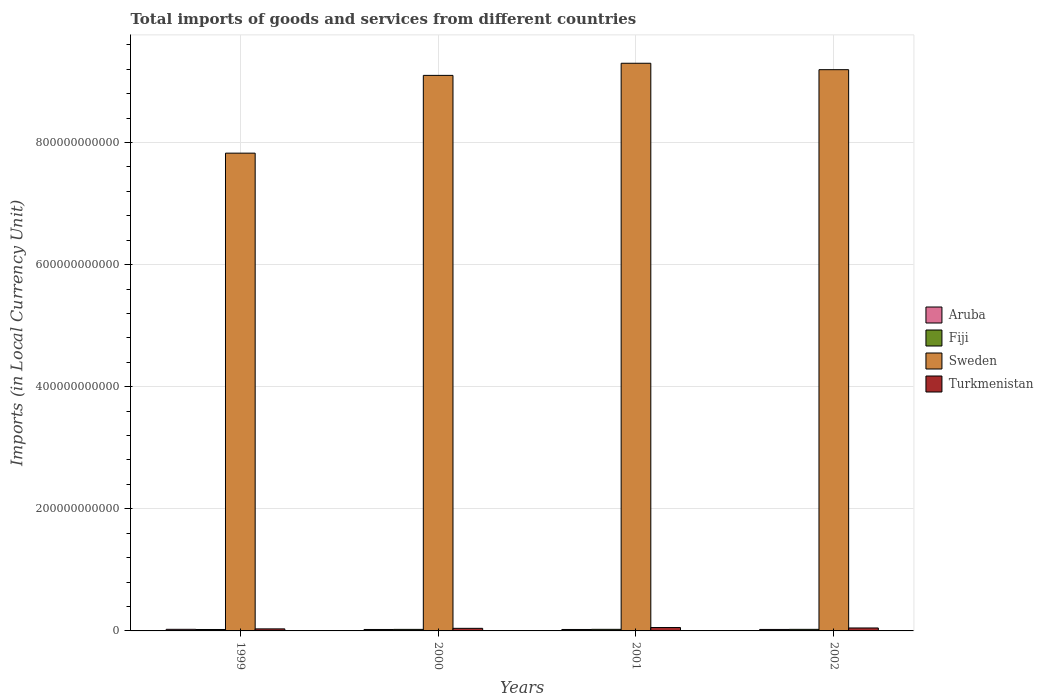How many groups of bars are there?
Your answer should be very brief. 4. Are the number of bars on each tick of the X-axis equal?
Offer a terse response. Yes. How many bars are there on the 3rd tick from the left?
Make the answer very short. 4. How many bars are there on the 4th tick from the right?
Provide a short and direct response. 4. What is the Amount of goods and services imports in Fiji in 1999?
Offer a terse response. 2.35e+09. Across all years, what is the maximum Amount of goods and services imports in Sweden?
Ensure brevity in your answer.  9.30e+11. Across all years, what is the minimum Amount of goods and services imports in Aruba?
Keep it short and to the point. 2.36e+09. In which year was the Amount of goods and services imports in Fiji maximum?
Provide a succinct answer. 2001. What is the total Amount of goods and services imports in Turkmenistan in the graph?
Your answer should be compact. 1.80e+1. What is the difference between the Amount of goods and services imports in Turkmenistan in 2001 and that in 2002?
Offer a very short reply. 7.11e+08. What is the difference between the Amount of goods and services imports in Fiji in 2000 and the Amount of goods and services imports in Turkmenistan in 2002?
Provide a short and direct response. -2.31e+09. What is the average Amount of goods and services imports in Turkmenistan per year?
Keep it short and to the point. 4.49e+09. In the year 2001, what is the difference between the Amount of goods and services imports in Sweden and Amount of goods and services imports in Aruba?
Your answer should be very brief. 9.27e+11. What is the ratio of the Amount of goods and services imports in Turkmenistan in 2000 to that in 2002?
Give a very brief answer. 0.87. Is the difference between the Amount of goods and services imports in Sweden in 2000 and 2001 greater than the difference between the Amount of goods and services imports in Aruba in 2000 and 2001?
Ensure brevity in your answer.  No. What is the difference between the highest and the second highest Amount of goods and services imports in Turkmenistan?
Provide a succinct answer. 7.11e+08. What is the difference between the highest and the lowest Amount of goods and services imports in Sweden?
Make the answer very short. 1.47e+11. In how many years, is the Amount of goods and services imports in Fiji greater than the average Amount of goods and services imports in Fiji taken over all years?
Your answer should be very brief. 3. Is the sum of the Amount of goods and services imports in Turkmenistan in 1999 and 2001 greater than the maximum Amount of goods and services imports in Fiji across all years?
Offer a very short reply. Yes. Is it the case that in every year, the sum of the Amount of goods and services imports in Turkmenistan and Amount of goods and services imports in Aruba is greater than the sum of Amount of goods and services imports in Fiji and Amount of goods and services imports in Sweden?
Give a very brief answer. Yes. What does the 2nd bar from the left in 1999 represents?
Your answer should be very brief. Fiji. What does the 4th bar from the right in 1999 represents?
Provide a short and direct response. Aruba. How many years are there in the graph?
Provide a succinct answer. 4. What is the difference between two consecutive major ticks on the Y-axis?
Ensure brevity in your answer.  2.00e+11. Are the values on the major ticks of Y-axis written in scientific E-notation?
Your answer should be compact. No. Does the graph contain any zero values?
Offer a very short reply. No. Does the graph contain grids?
Offer a terse response. Yes. Where does the legend appear in the graph?
Make the answer very short. Center right. What is the title of the graph?
Your response must be concise. Total imports of goods and services from different countries. Does "Italy" appear as one of the legend labels in the graph?
Your answer should be very brief. No. What is the label or title of the X-axis?
Make the answer very short. Years. What is the label or title of the Y-axis?
Give a very brief answer. Imports (in Local Currency Unit). What is the Imports (in Local Currency Unit) of Aruba in 1999?
Make the answer very short. 2.61e+09. What is the Imports (in Local Currency Unit) of Fiji in 1999?
Keep it short and to the point. 2.35e+09. What is the Imports (in Local Currency Unit) of Sweden in 1999?
Keep it short and to the point. 7.83e+11. What is the Imports (in Local Currency Unit) in Turkmenistan in 1999?
Ensure brevity in your answer.  3.35e+09. What is the Imports (in Local Currency Unit) in Aruba in 2000?
Provide a succinct answer. 2.37e+09. What is the Imports (in Local Currency Unit) of Fiji in 2000?
Provide a short and direct response. 2.52e+09. What is the Imports (in Local Currency Unit) of Sweden in 2000?
Make the answer very short. 9.10e+11. What is the Imports (in Local Currency Unit) of Turkmenistan in 2000?
Give a very brief answer. 4.23e+09. What is the Imports (in Local Currency Unit) in Aruba in 2001?
Keep it short and to the point. 2.36e+09. What is the Imports (in Local Currency Unit) of Fiji in 2001?
Keep it short and to the point. 2.60e+09. What is the Imports (in Local Currency Unit) of Sweden in 2001?
Give a very brief answer. 9.30e+11. What is the Imports (in Local Currency Unit) in Turkmenistan in 2001?
Your response must be concise. 5.54e+09. What is the Imports (in Local Currency Unit) in Aruba in 2002?
Offer a terse response. 2.41e+09. What is the Imports (in Local Currency Unit) in Fiji in 2002?
Give a very brief answer. 2.58e+09. What is the Imports (in Local Currency Unit) in Sweden in 2002?
Provide a short and direct response. 9.19e+11. What is the Imports (in Local Currency Unit) in Turkmenistan in 2002?
Provide a succinct answer. 4.83e+09. Across all years, what is the maximum Imports (in Local Currency Unit) in Aruba?
Offer a very short reply. 2.61e+09. Across all years, what is the maximum Imports (in Local Currency Unit) in Fiji?
Make the answer very short. 2.60e+09. Across all years, what is the maximum Imports (in Local Currency Unit) of Sweden?
Your answer should be compact. 9.30e+11. Across all years, what is the maximum Imports (in Local Currency Unit) of Turkmenistan?
Your response must be concise. 5.54e+09. Across all years, what is the minimum Imports (in Local Currency Unit) in Aruba?
Your answer should be compact. 2.36e+09. Across all years, what is the minimum Imports (in Local Currency Unit) in Fiji?
Your answer should be compact. 2.35e+09. Across all years, what is the minimum Imports (in Local Currency Unit) in Sweden?
Offer a very short reply. 7.83e+11. Across all years, what is the minimum Imports (in Local Currency Unit) in Turkmenistan?
Give a very brief answer. 3.35e+09. What is the total Imports (in Local Currency Unit) of Aruba in the graph?
Offer a very short reply. 9.75e+09. What is the total Imports (in Local Currency Unit) of Fiji in the graph?
Your response must be concise. 1.00e+1. What is the total Imports (in Local Currency Unit) in Sweden in the graph?
Make the answer very short. 3.54e+12. What is the total Imports (in Local Currency Unit) in Turkmenistan in the graph?
Give a very brief answer. 1.80e+1. What is the difference between the Imports (in Local Currency Unit) of Aruba in 1999 and that in 2000?
Offer a terse response. 2.40e+08. What is the difference between the Imports (in Local Currency Unit) in Fiji in 1999 and that in 2000?
Keep it short and to the point. -1.69e+08. What is the difference between the Imports (in Local Currency Unit) of Sweden in 1999 and that in 2000?
Your answer should be compact. -1.27e+11. What is the difference between the Imports (in Local Currency Unit) in Turkmenistan in 1999 and that in 2000?
Provide a succinct answer. -8.78e+08. What is the difference between the Imports (in Local Currency Unit) in Aruba in 1999 and that in 2001?
Keep it short and to the point. 2.54e+08. What is the difference between the Imports (in Local Currency Unit) of Fiji in 1999 and that in 2001?
Keep it short and to the point. -2.48e+08. What is the difference between the Imports (in Local Currency Unit) in Sweden in 1999 and that in 2001?
Offer a terse response. -1.47e+11. What is the difference between the Imports (in Local Currency Unit) in Turkmenistan in 1999 and that in 2001?
Make the answer very short. -2.19e+09. What is the difference between the Imports (in Local Currency Unit) of Aruba in 1999 and that in 2002?
Keep it short and to the point. 1.99e+08. What is the difference between the Imports (in Local Currency Unit) of Fiji in 1999 and that in 2002?
Your answer should be very brief. -2.26e+08. What is the difference between the Imports (in Local Currency Unit) of Sweden in 1999 and that in 2002?
Ensure brevity in your answer.  -1.37e+11. What is the difference between the Imports (in Local Currency Unit) of Turkmenistan in 1999 and that in 2002?
Your answer should be very brief. -1.48e+09. What is the difference between the Imports (in Local Currency Unit) in Aruba in 2000 and that in 2001?
Offer a very short reply. 1.48e+07. What is the difference between the Imports (in Local Currency Unit) in Fiji in 2000 and that in 2001?
Provide a succinct answer. -7.86e+07. What is the difference between the Imports (in Local Currency Unit) of Sweden in 2000 and that in 2001?
Offer a terse response. -1.99e+1. What is the difference between the Imports (in Local Currency Unit) of Turkmenistan in 2000 and that in 2001?
Give a very brief answer. -1.32e+09. What is the difference between the Imports (in Local Currency Unit) of Aruba in 2000 and that in 2002?
Provide a short and direct response. -4.09e+07. What is the difference between the Imports (in Local Currency Unit) of Fiji in 2000 and that in 2002?
Give a very brief answer. -5.72e+07. What is the difference between the Imports (in Local Currency Unit) in Sweden in 2000 and that in 2002?
Provide a short and direct response. -9.34e+09. What is the difference between the Imports (in Local Currency Unit) of Turkmenistan in 2000 and that in 2002?
Provide a succinct answer. -6.05e+08. What is the difference between the Imports (in Local Currency Unit) in Aruba in 2001 and that in 2002?
Your answer should be compact. -5.57e+07. What is the difference between the Imports (in Local Currency Unit) in Fiji in 2001 and that in 2002?
Your answer should be compact. 2.14e+07. What is the difference between the Imports (in Local Currency Unit) of Sweden in 2001 and that in 2002?
Offer a very short reply. 1.05e+1. What is the difference between the Imports (in Local Currency Unit) of Turkmenistan in 2001 and that in 2002?
Keep it short and to the point. 7.11e+08. What is the difference between the Imports (in Local Currency Unit) in Aruba in 1999 and the Imports (in Local Currency Unit) in Fiji in 2000?
Make the answer very short. 9.14e+07. What is the difference between the Imports (in Local Currency Unit) of Aruba in 1999 and the Imports (in Local Currency Unit) of Sweden in 2000?
Your answer should be very brief. -9.07e+11. What is the difference between the Imports (in Local Currency Unit) in Aruba in 1999 and the Imports (in Local Currency Unit) in Turkmenistan in 2000?
Offer a terse response. -1.62e+09. What is the difference between the Imports (in Local Currency Unit) of Fiji in 1999 and the Imports (in Local Currency Unit) of Sweden in 2000?
Your answer should be very brief. -9.08e+11. What is the difference between the Imports (in Local Currency Unit) in Fiji in 1999 and the Imports (in Local Currency Unit) in Turkmenistan in 2000?
Your answer should be very brief. -1.88e+09. What is the difference between the Imports (in Local Currency Unit) of Sweden in 1999 and the Imports (in Local Currency Unit) of Turkmenistan in 2000?
Offer a very short reply. 7.78e+11. What is the difference between the Imports (in Local Currency Unit) in Aruba in 1999 and the Imports (in Local Currency Unit) in Fiji in 2001?
Your answer should be compact. 1.28e+07. What is the difference between the Imports (in Local Currency Unit) of Aruba in 1999 and the Imports (in Local Currency Unit) of Sweden in 2001?
Provide a short and direct response. -9.27e+11. What is the difference between the Imports (in Local Currency Unit) in Aruba in 1999 and the Imports (in Local Currency Unit) in Turkmenistan in 2001?
Provide a succinct answer. -2.93e+09. What is the difference between the Imports (in Local Currency Unit) of Fiji in 1999 and the Imports (in Local Currency Unit) of Sweden in 2001?
Ensure brevity in your answer.  -9.28e+11. What is the difference between the Imports (in Local Currency Unit) of Fiji in 1999 and the Imports (in Local Currency Unit) of Turkmenistan in 2001?
Your answer should be very brief. -3.19e+09. What is the difference between the Imports (in Local Currency Unit) of Sweden in 1999 and the Imports (in Local Currency Unit) of Turkmenistan in 2001?
Make the answer very short. 7.77e+11. What is the difference between the Imports (in Local Currency Unit) of Aruba in 1999 and the Imports (in Local Currency Unit) of Fiji in 2002?
Offer a very short reply. 3.42e+07. What is the difference between the Imports (in Local Currency Unit) of Aruba in 1999 and the Imports (in Local Currency Unit) of Sweden in 2002?
Ensure brevity in your answer.  -9.17e+11. What is the difference between the Imports (in Local Currency Unit) of Aruba in 1999 and the Imports (in Local Currency Unit) of Turkmenistan in 2002?
Your answer should be very brief. -2.22e+09. What is the difference between the Imports (in Local Currency Unit) in Fiji in 1999 and the Imports (in Local Currency Unit) in Sweden in 2002?
Keep it short and to the point. -9.17e+11. What is the difference between the Imports (in Local Currency Unit) of Fiji in 1999 and the Imports (in Local Currency Unit) of Turkmenistan in 2002?
Offer a very short reply. -2.48e+09. What is the difference between the Imports (in Local Currency Unit) of Sweden in 1999 and the Imports (in Local Currency Unit) of Turkmenistan in 2002?
Your response must be concise. 7.78e+11. What is the difference between the Imports (in Local Currency Unit) of Aruba in 2000 and the Imports (in Local Currency Unit) of Fiji in 2001?
Make the answer very short. -2.27e+08. What is the difference between the Imports (in Local Currency Unit) of Aruba in 2000 and the Imports (in Local Currency Unit) of Sweden in 2001?
Your answer should be compact. -9.27e+11. What is the difference between the Imports (in Local Currency Unit) of Aruba in 2000 and the Imports (in Local Currency Unit) of Turkmenistan in 2001?
Offer a very short reply. -3.17e+09. What is the difference between the Imports (in Local Currency Unit) in Fiji in 2000 and the Imports (in Local Currency Unit) in Sweden in 2001?
Your answer should be compact. -9.27e+11. What is the difference between the Imports (in Local Currency Unit) of Fiji in 2000 and the Imports (in Local Currency Unit) of Turkmenistan in 2001?
Make the answer very short. -3.02e+09. What is the difference between the Imports (in Local Currency Unit) in Sweden in 2000 and the Imports (in Local Currency Unit) in Turkmenistan in 2001?
Your answer should be very brief. 9.04e+11. What is the difference between the Imports (in Local Currency Unit) in Aruba in 2000 and the Imports (in Local Currency Unit) in Fiji in 2002?
Provide a succinct answer. -2.06e+08. What is the difference between the Imports (in Local Currency Unit) in Aruba in 2000 and the Imports (in Local Currency Unit) in Sweden in 2002?
Keep it short and to the point. -9.17e+11. What is the difference between the Imports (in Local Currency Unit) in Aruba in 2000 and the Imports (in Local Currency Unit) in Turkmenistan in 2002?
Keep it short and to the point. -2.46e+09. What is the difference between the Imports (in Local Currency Unit) of Fiji in 2000 and the Imports (in Local Currency Unit) of Sweden in 2002?
Your response must be concise. -9.17e+11. What is the difference between the Imports (in Local Currency Unit) in Fiji in 2000 and the Imports (in Local Currency Unit) in Turkmenistan in 2002?
Provide a succinct answer. -2.31e+09. What is the difference between the Imports (in Local Currency Unit) in Sweden in 2000 and the Imports (in Local Currency Unit) in Turkmenistan in 2002?
Your response must be concise. 9.05e+11. What is the difference between the Imports (in Local Currency Unit) in Aruba in 2001 and the Imports (in Local Currency Unit) in Fiji in 2002?
Keep it short and to the point. -2.20e+08. What is the difference between the Imports (in Local Currency Unit) of Aruba in 2001 and the Imports (in Local Currency Unit) of Sweden in 2002?
Your answer should be compact. -9.17e+11. What is the difference between the Imports (in Local Currency Unit) in Aruba in 2001 and the Imports (in Local Currency Unit) in Turkmenistan in 2002?
Provide a short and direct response. -2.48e+09. What is the difference between the Imports (in Local Currency Unit) of Fiji in 2001 and the Imports (in Local Currency Unit) of Sweden in 2002?
Make the answer very short. -9.17e+11. What is the difference between the Imports (in Local Currency Unit) in Fiji in 2001 and the Imports (in Local Currency Unit) in Turkmenistan in 2002?
Ensure brevity in your answer.  -2.23e+09. What is the difference between the Imports (in Local Currency Unit) of Sweden in 2001 and the Imports (in Local Currency Unit) of Turkmenistan in 2002?
Make the answer very short. 9.25e+11. What is the average Imports (in Local Currency Unit) in Aruba per year?
Provide a succinct answer. 2.44e+09. What is the average Imports (in Local Currency Unit) of Fiji per year?
Give a very brief answer. 2.51e+09. What is the average Imports (in Local Currency Unit) of Sweden per year?
Your response must be concise. 8.85e+11. What is the average Imports (in Local Currency Unit) in Turkmenistan per year?
Provide a short and direct response. 4.49e+09. In the year 1999, what is the difference between the Imports (in Local Currency Unit) in Aruba and Imports (in Local Currency Unit) in Fiji?
Offer a very short reply. 2.61e+08. In the year 1999, what is the difference between the Imports (in Local Currency Unit) of Aruba and Imports (in Local Currency Unit) of Sweden?
Offer a terse response. -7.80e+11. In the year 1999, what is the difference between the Imports (in Local Currency Unit) of Aruba and Imports (in Local Currency Unit) of Turkmenistan?
Your answer should be very brief. -7.39e+08. In the year 1999, what is the difference between the Imports (in Local Currency Unit) of Fiji and Imports (in Local Currency Unit) of Sweden?
Ensure brevity in your answer.  -7.80e+11. In the year 1999, what is the difference between the Imports (in Local Currency Unit) of Fiji and Imports (in Local Currency Unit) of Turkmenistan?
Your answer should be very brief. -1.00e+09. In the year 1999, what is the difference between the Imports (in Local Currency Unit) in Sweden and Imports (in Local Currency Unit) in Turkmenistan?
Make the answer very short. 7.79e+11. In the year 2000, what is the difference between the Imports (in Local Currency Unit) of Aruba and Imports (in Local Currency Unit) of Fiji?
Your answer should be very brief. -1.48e+08. In the year 2000, what is the difference between the Imports (in Local Currency Unit) in Aruba and Imports (in Local Currency Unit) in Sweden?
Give a very brief answer. -9.08e+11. In the year 2000, what is the difference between the Imports (in Local Currency Unit) of Aruba and Imports (in Local Currency Unit) of Turkmenistan?
Your answer should be very brief. -1.86e+09. In the year 2000, what is the difference between the Imports (in Local Currency Unit) of Fiji and Imports (in Local Currency Unit) of Sweden?
Provide a short and direct response. -9.07e+11. In the year 2000, what is the difference between the Imports (in Local Currency Unit) in Fiji and Imports (in Local Currency Unit) in Turkmenistan?
Your response must be concise. -1.71e+09. In the year 2000, what is the difference between the Imports (in Local Currency Unit) of Sweden and Imports (in Local Currency Unit) of Turkmenistan?
Give a very brief answer. 9.06e+11. In the year 2001, what is the difference between the Imports (in Local Currency Unit) in Aruba and Imports (in Local Currency Unit) in Fiji?
Provide a succinct answer. -2.42e+08. In the year 2001, what is the difference between the Imports (in Local Currency Unit) of Aruba and Imports (in Local Currency Unit) of Sweden?
Keep it short and to the point. -9.27e+11. In the year 2001, what is the difference between the Imports (in Local Currency Unit) of Aruba and Imports (in Local Currency Unit) of Turkmenistan?
Your answer should be very brief. -3.19e+09. In the year 2001, what is the difference between the Imports (in Local Currency Unit) of Fiji and Imports (in Local Currency Unit) of Sweden?
Make the answer very short. -9.27e+11. In the year 2001, what is the difference between the Imports (in Local Currency Unit) in Fiji and Imports (in Local Currency Unit) in Turkmenistan?
Your answer should be compact. -2.95e+09. In the year 2001, what is the difference between the Imports (in Local Currency Unit) in Sweden and Imports (in Local Currency Unit) in Turkmenistan?
Offer a terse response. 9.24e+11. In the year 2002, what is the difference between the Imports (in Local Currency Unit) of Aruba and Imports (in Local Currency Unit) of Fiji?
Your answer should be very brief. -1.65e+08. In the year 2002, what is the difference between the Imports (in Local Currency Unit) in Aruba and Imports (in Local Currency Unit) in Sweden?
Keep it short and to the point. -9.17e+11. In the year 2002, what is the difference between the Imports (in Local Currency Unit) of Aruba and Imports (in Local Currency Unit) of Turkmenistan?
Provide a short and direct response. -2.42e+09. In the year 2002, what is the difference between the Imports (in Local Currency Unit) in Fiji and Imports (in Local Currency Unit) in Sweden?
Keep it short and to the point. -9.17e+11. In the year 2002, what is the difference between the Imports (in Local Currency Unit) of Fiji and Imports (in Local Currency Unit) of Turkmenistan?
Offer a terse response. -2.26e+09. In the year 2002, what is the difference between the Imports (in Local Currency Unit) of Sweden and Imports (in Local Currency Unit) of Turkmenistan?
Give a very brief answer. 9.15e+11. What is the ratio of the Imports (in Local Currency Unit) in Aruba in 1999 to that in 2000?
Offer a terse response. 1.1. What is the ratio of the Imports (in Local Currency Unit) of Fiji in 1999 to that in 2000?
Make the answer very short. 0.93. What is the ratio of the Imports (in Local Currency Unit) in Sweden in 1999 to that in 2000?
Offer a terse response. 0.86. What is the ratio of the Imports (in Local Currency Unit) of Turkmenistan in 1999 to that in 2000?
Your response must be concise. 0.79. What is the ratio of the Imports (in Local Currency Unit) in Aruba in 1999 to that in 2001?
Ensure brevity in your answer.  1.11. What is the ratio of the Imports (in Local Currency Unit) of Fiji in 1999 to that in 2001?
Keep it short and to the point. 0.9. What is the ratio of the Imports (in Local Currency Unit) of Sweden in 1999 to that in 2001?
Your answer should be very brief. 0.84. What is the ratio of the Imports (in Local Currency Unit) in Turkmenistan in 1999 to that in 2001?
Offer a very short reply. 0.6. What is the ratio of the Imports (in Local Currency Unit) in Aruba in 1999 to that in 2002?
Provide a succinct answer. 1.08. What is the ratio of the Imports (in Local Currency Unit) in Fiji in 1999 to that in 2002?
Offer a very short reply. 0.91. What is the ratio of the Imports (in Local Currency Unit) in Sweden in 1999 to that in 2002?
Offer a terse response. 0.85. What is the ratio of the Imports (in Local Currency Unit) in Turkmenistan in 1999 to that in 2002?
Your answer should be compact. 0.69. What is the ratio of the Imports (in Local Currency Unit) of Fiji in 2000 to that in 2001?
Give a very brief answer. 0.97. What is the ratio of the Imports (in Local Currency Unit) of Sweden in 2000 to that in 2001?
Offer a very short reply. 0.98. What is the ratio of the Imports (in Local Currency Unit) of Turkmenistan in 2000 to that in 2001?
Your answer should be compact. 0.76. What is the ratio of the Imports (in Local Currency Unit) in Aruba in 2000 to that in 2002?
Your answer should be compact. 0.98. What is the ratio of the Imports (in Local Currency Unit) in Fiji in 2000 to that in 2002?
Make the answer very short. 0.98. What is the ratio of the Imports (in Local Currency Unit) in Sweden in 2000 to that in 2002?
Provide a succinct answer. 0.99. What is the ratio of the Imports (in Local Currency Unit) in Turkmenistan in 2000 to that in 2002?
Your response must be concise. 0.87. What is the ratio of the Imports (in Local Currency Unit) of Aruba in 2001 to that in 2002?
Make the answer very short. 0.98. What is the ratio of the Imports (in Local Currency Unit) of Fiji in 2001 to that in 2002?
Provide a succinct answer. 1.01. What is the ratio of the Imports (in Local Currency Unit) of Sweden in 2001 to that in 2002?
Your answer should be very brief. 1.01. What is the ratio of the Imports (in Local Currency Unit) of Turkmenistan in 2001 to that in 2002?
Offer a terse response. 1.15. What is the difference between the highest and the second highest Imports (in Local Currency Unit) in Aruba?
Provide a succinct answer. 1.99e+08. What is the difference between the highest and the second highest Imports (in Local Currency Unit) in Fiji?
Your answer should be very brief. 2.14e+07. What is the difference between the highest and the second highest Imports (in Local Currency Unit) in Sweden?
Keep it short and to the point. 1.05e+1. What is the difference between the highest and the second highest Imports (in Local Currency Unit) of Turkmenistan?
Keep it short and to the point. 7.11e+08. What is the difference between the highest and the lowest Imports (in Local Currency Unit) in Aruba?
Make the answer very short. 2.54e+08. What is the difference between the highest and the lowest Imports (in Local Currency Unit) of Fiji?
Your response must be concise. 2.48e+08. What is the difference between the highest and the lowest Imports (in Local Currency Unit) in Sweden?
Offer a terse response. 1.47e+11. What is the difference between the highest and the lowest Imports (in Local Currency Unit) of Turkmenistan?
Offer a terse response. 2.19e+09. 